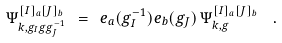<formula> <loc_0><loc_0><loc_500><loc_500>\Psi _ { k , g _ { I } g g _ { J } ^ { - 1 } } ^ { [ I ] _ { a } [ J ] _ { b } } \ = \ e _ { a } ( g _ { I } ^ { - 1 } ) e _ { b } ( g _ { J } ) \, \Psi _ { k , g } ^ { [ I ] _ { a } [ J ] _ { b } } \ \ .</formula> 